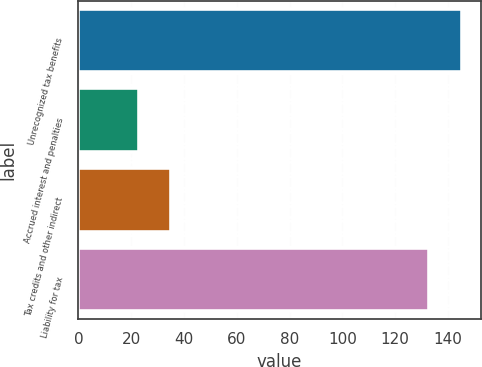Convert chart to OTSL. <chart><loc_0><loc_0><loc_500><loc_500><bar_chart><fcel>Unrecognized tax benefits<fcel>Accrued interest and penalties<fcel>Tax credits and other indirect<fcel>Liability for tax<nl><fcel>145.2<fcel>23<fcel>35.2<fcel>133<nl></chart> 